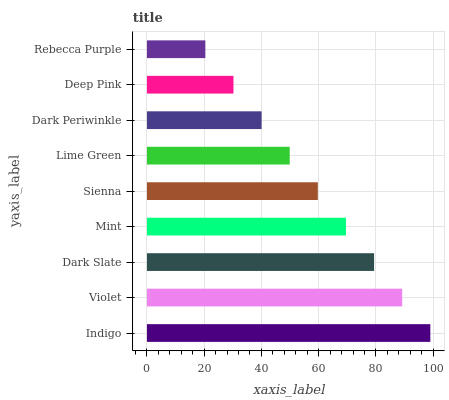Is Rebecca Purple the minimum?
Answer yes or no. Yes. Is Indigo the maximum?
Answer yes or no. Yes. Is Violet the minimum?
Answer yes or no. No. Is Violet the maximum?
Answer yes or no. No. Is Indigo greater than Violet?
Answer yes or no. Yes. Is Violet less than Indigo?
Answer yes or no. Yes. Is Violet greater than Indigo?
Answer yes or no. No. Is Indigo less than Violet?
Answer yes or no. No. Is Sienna the high median?
Answer yes or no. Yes. Is Sienna the low median?
Answer yes or no. Yes. Is Violet the high median?
Answer yes or no. No. Is Dark Periwinkle the low median?
Answer yes or no. No. 